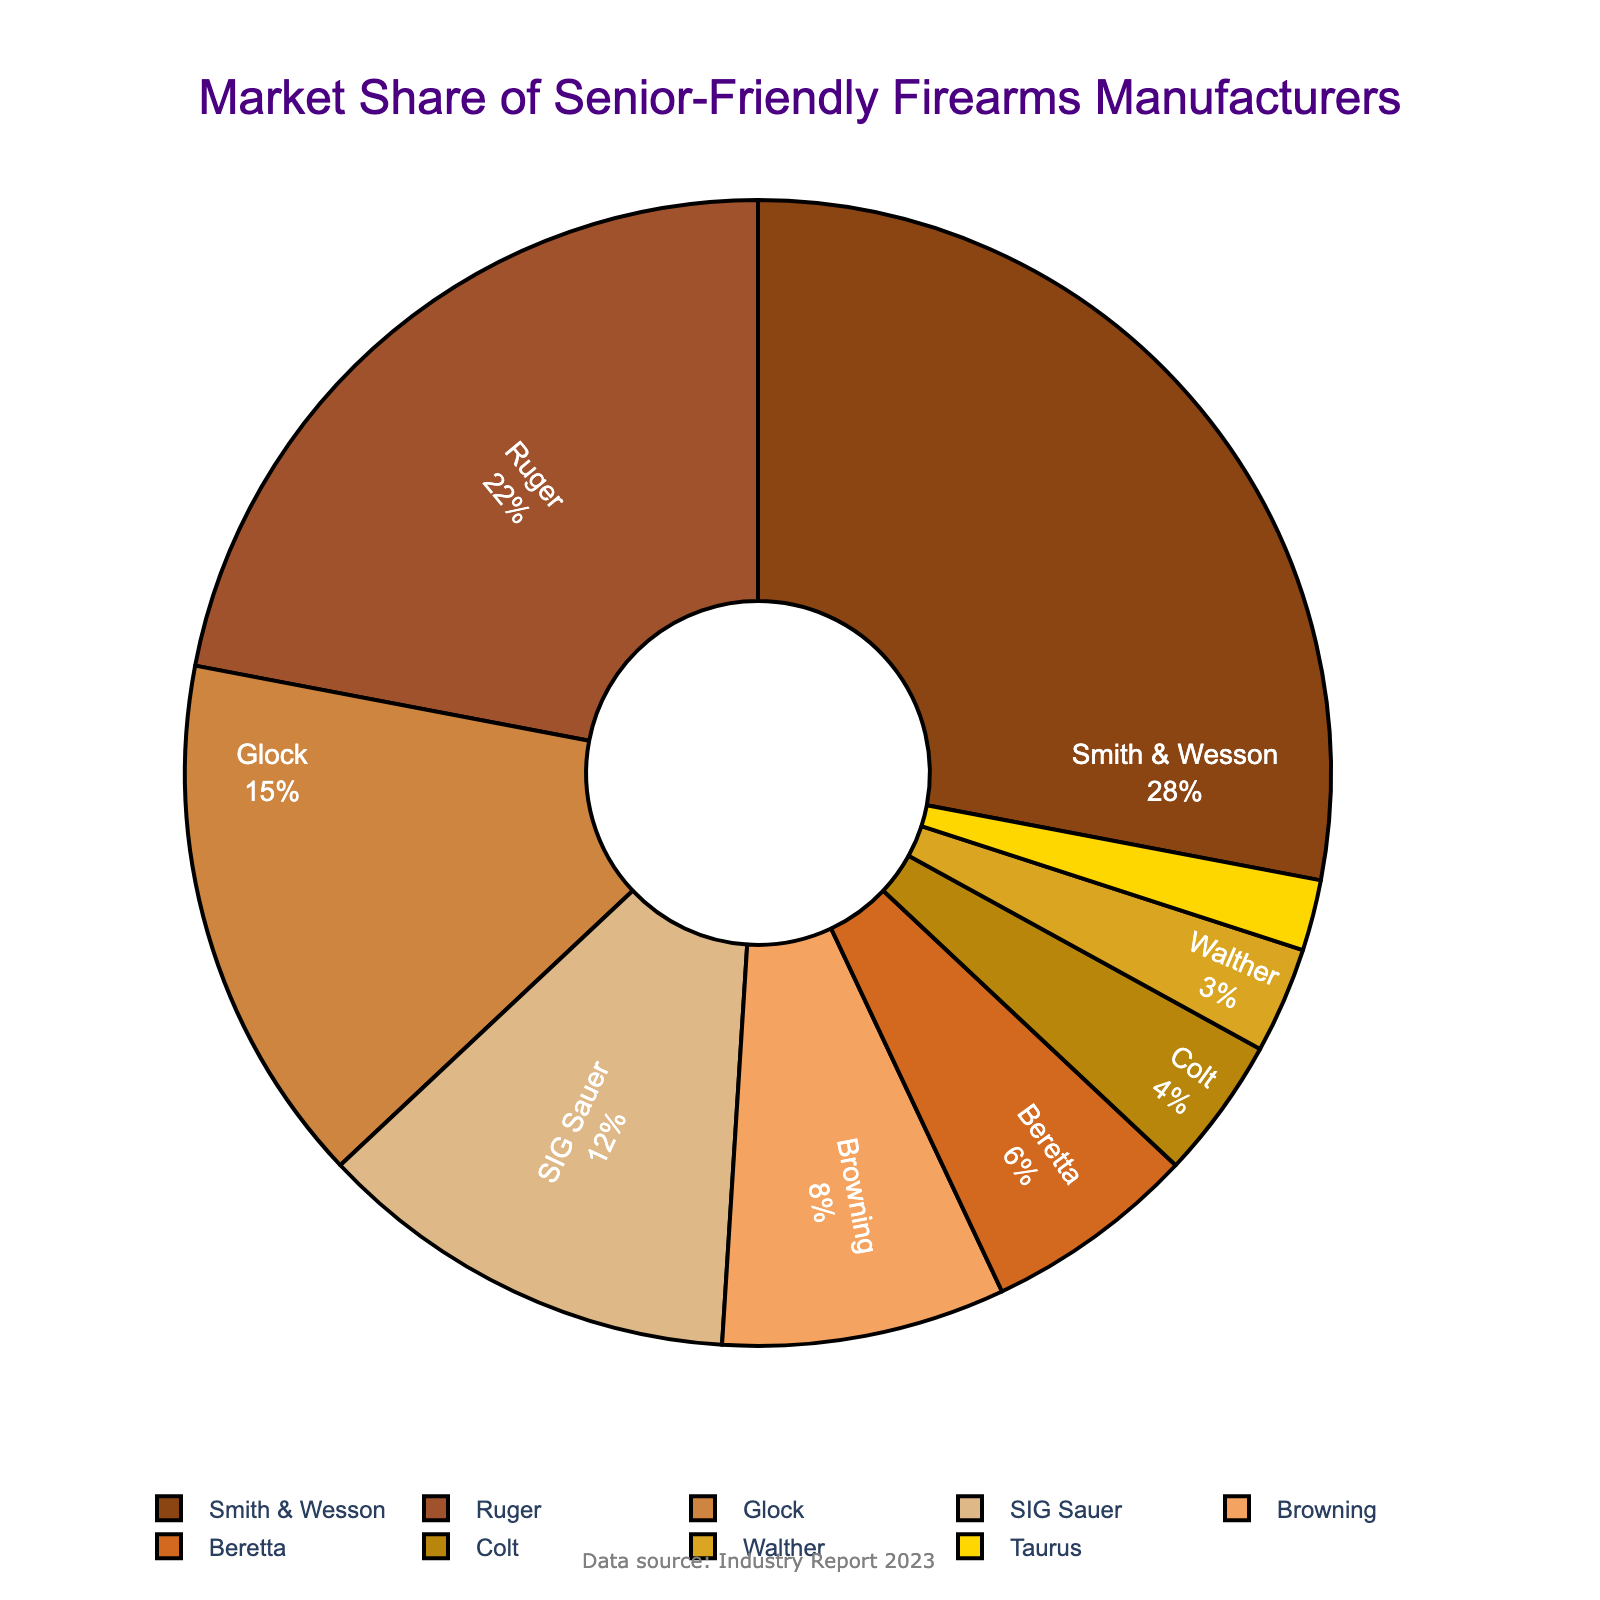Which manufacturer has the largest market share? According to the pie chart, the segment labeled "Smith & Wesson" is the largest in size. Smith & Wesson has the largest market share.
Answer: Smith & Wesson What is the total market share of Glock and SIG Sauer? To find the total, add the market shares of Glock (15%) and SIG Sauer (12%). So, 15 + 12 = 27%.
Answer: 27% Which manufacturers have a market share greater than 20%? The pie chart shows that Smith & Wesson has 28%, and Ruger has 22%, both of which are greater than 20%.
Answer: Smith & Wesson, Ruger Is the market share of Beretta greater than that of Colt and Walther combined? The market share for Beretta is 6%. The market shares for Colt and Walther combined are 4% + 3% = 7%. Since 6% is less than 7%, Beretta's market share is not greater.
Answer: No What is the difference in market share between the largest and smallest manufacturers? The largest manufacturer, Smith & Wesson, has a 28% market share, and the smallest, Taurus, has a 2% market share. The difference is 28% - 2% = 26%.
Answer: 26% Which segment is colored in gold? According to the color mapping in the code, the gold color corresponds to the last color assigned, which is Taurus.
Answer: Taurus How many manufacturers have a market share of less than 10%? The manufacturers with less than 10% market share are Browning (8%), Beretta (6%), Colt (4%), Walther (3%), and Taurus (2%). That makes a total of 5 manufacturers.
Answer: 5 What is the average market share of the manufacturers below 10%? First, sum the shares of manufacturers below 10%: 8% (Browning) + 6% (Beretta) + 4% (Colt) + 3% (Walther) + 2% (Taurus) = 23%. Then divide by the number of manufacturers (5). 23 / 5 = 4.6%.
Answer: 4.6% By how much does the market share of Ruger exceed that of Glock? The market share of Ruger is 22%, and that of Glock is 15%. The difference is 22% - 15% = 7%.
Answer: 7% What is the combined market share of the top three manufacturers? The top three manufacturers are Smith & Wesson (28%), Ruger (22%), and Glock (15%). Their combined market share is 28% + 22% + 15% = 65%.
Answer: 65% 